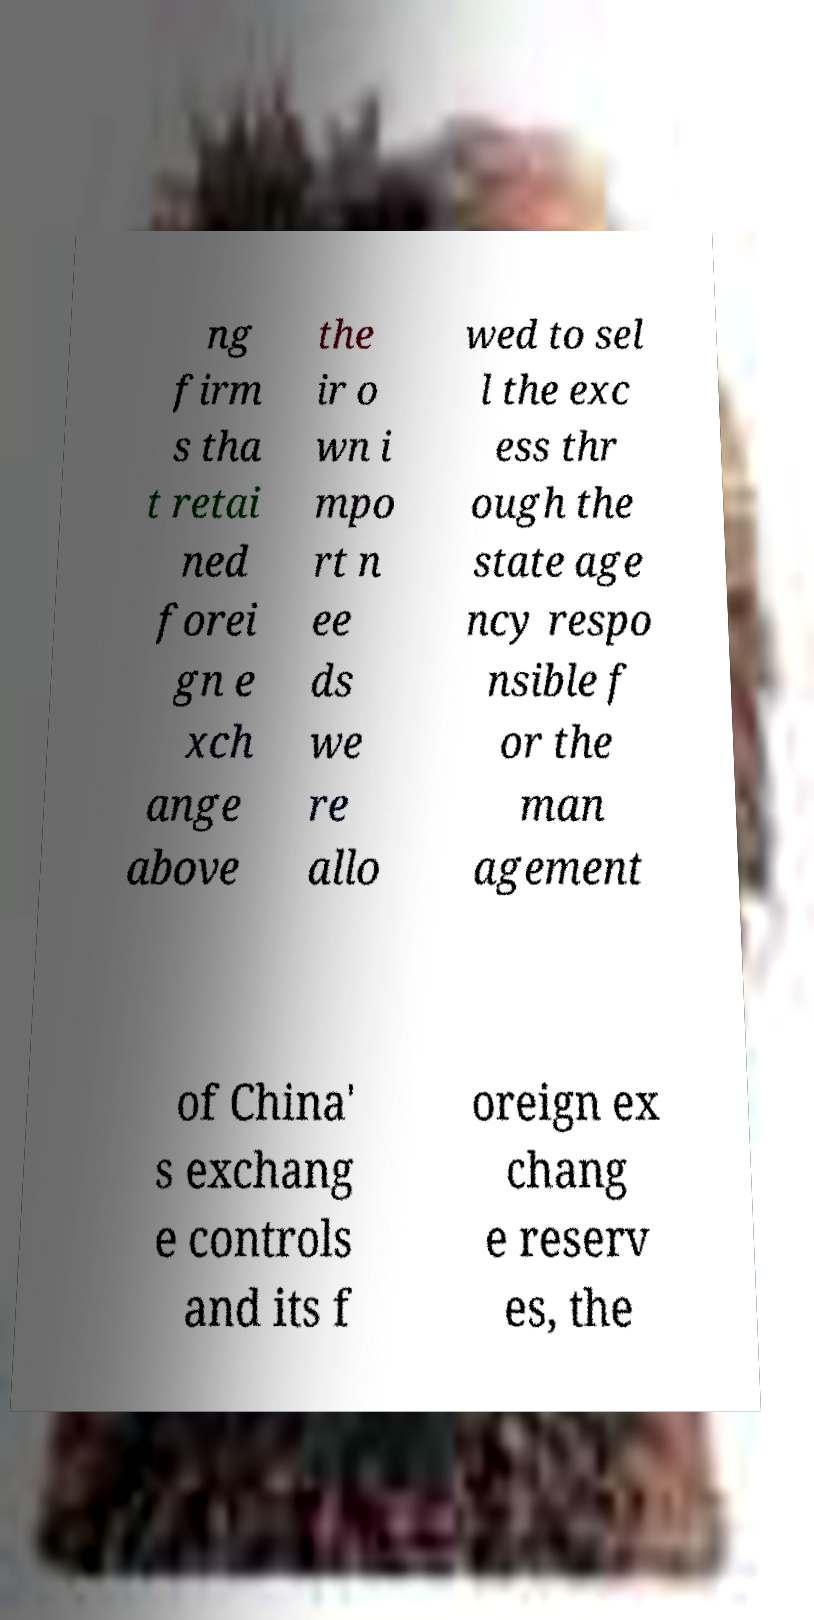I need the written content from this picture converted into text. Can you do that? ng firm s tha t retai ned forei gn e xch ange above the ir o wn i mpo rt n ee ds we re allo wed to sel l the exc ess thr ough the state age ncy respo nsible f or the man agement of China' s exchang e controls and its f oreign ex chang e reserv es, the 